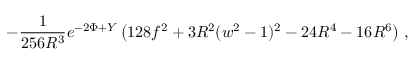Convert formula to latex. <formula><loc_0><loc_0><loc_500><loc_500>- \frac { 1 } { 2 5 6 R ^ { 3 } } e ^ { - 2 \Phi + Y } \left ( 1 2 8 f ^ { 2 } + 3 R ^ { 2 } ( w ^ { 2 } - 1 ) ^ { 2 } - 2 4 R ^ { 4 } - 1 6 R ^ { 6 } \right ) \, ,</formula> 